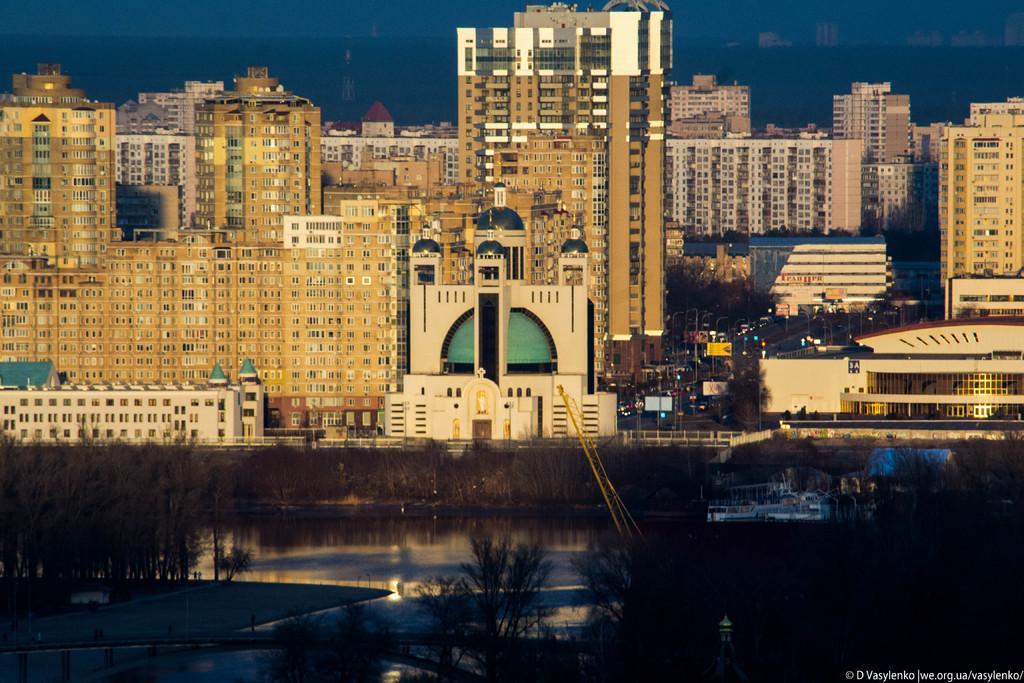Could you give a brief overview of what you see in this image? In this image in the front there are trees and in the center there is water. In the background there are buildings, vehicles and poles and trees. 